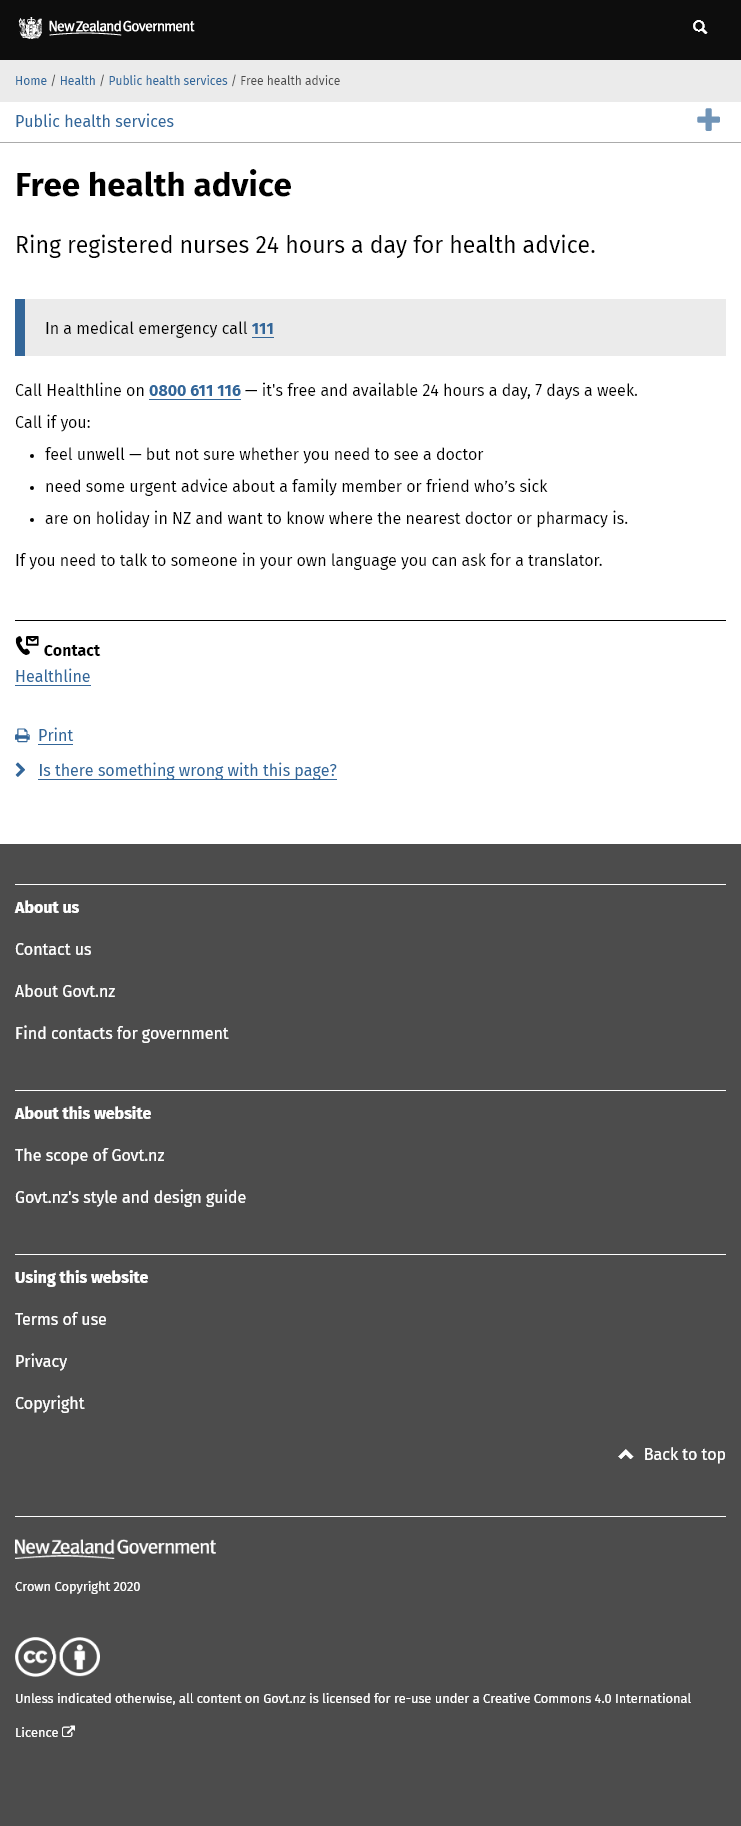Identify some key points in this picture. In the event of a medical emergency, you should immediately call the designated number, which is 111. It is advisable to contact Healthline when you are feeling unwell and require urgent advice, if you need assistance regarding a sick family member or friend, or if you are vacationing in New Zealand and require information on the nearest doctor or pharmacy. Yes, Healthline is a free service that can be called without incurring any charges. 